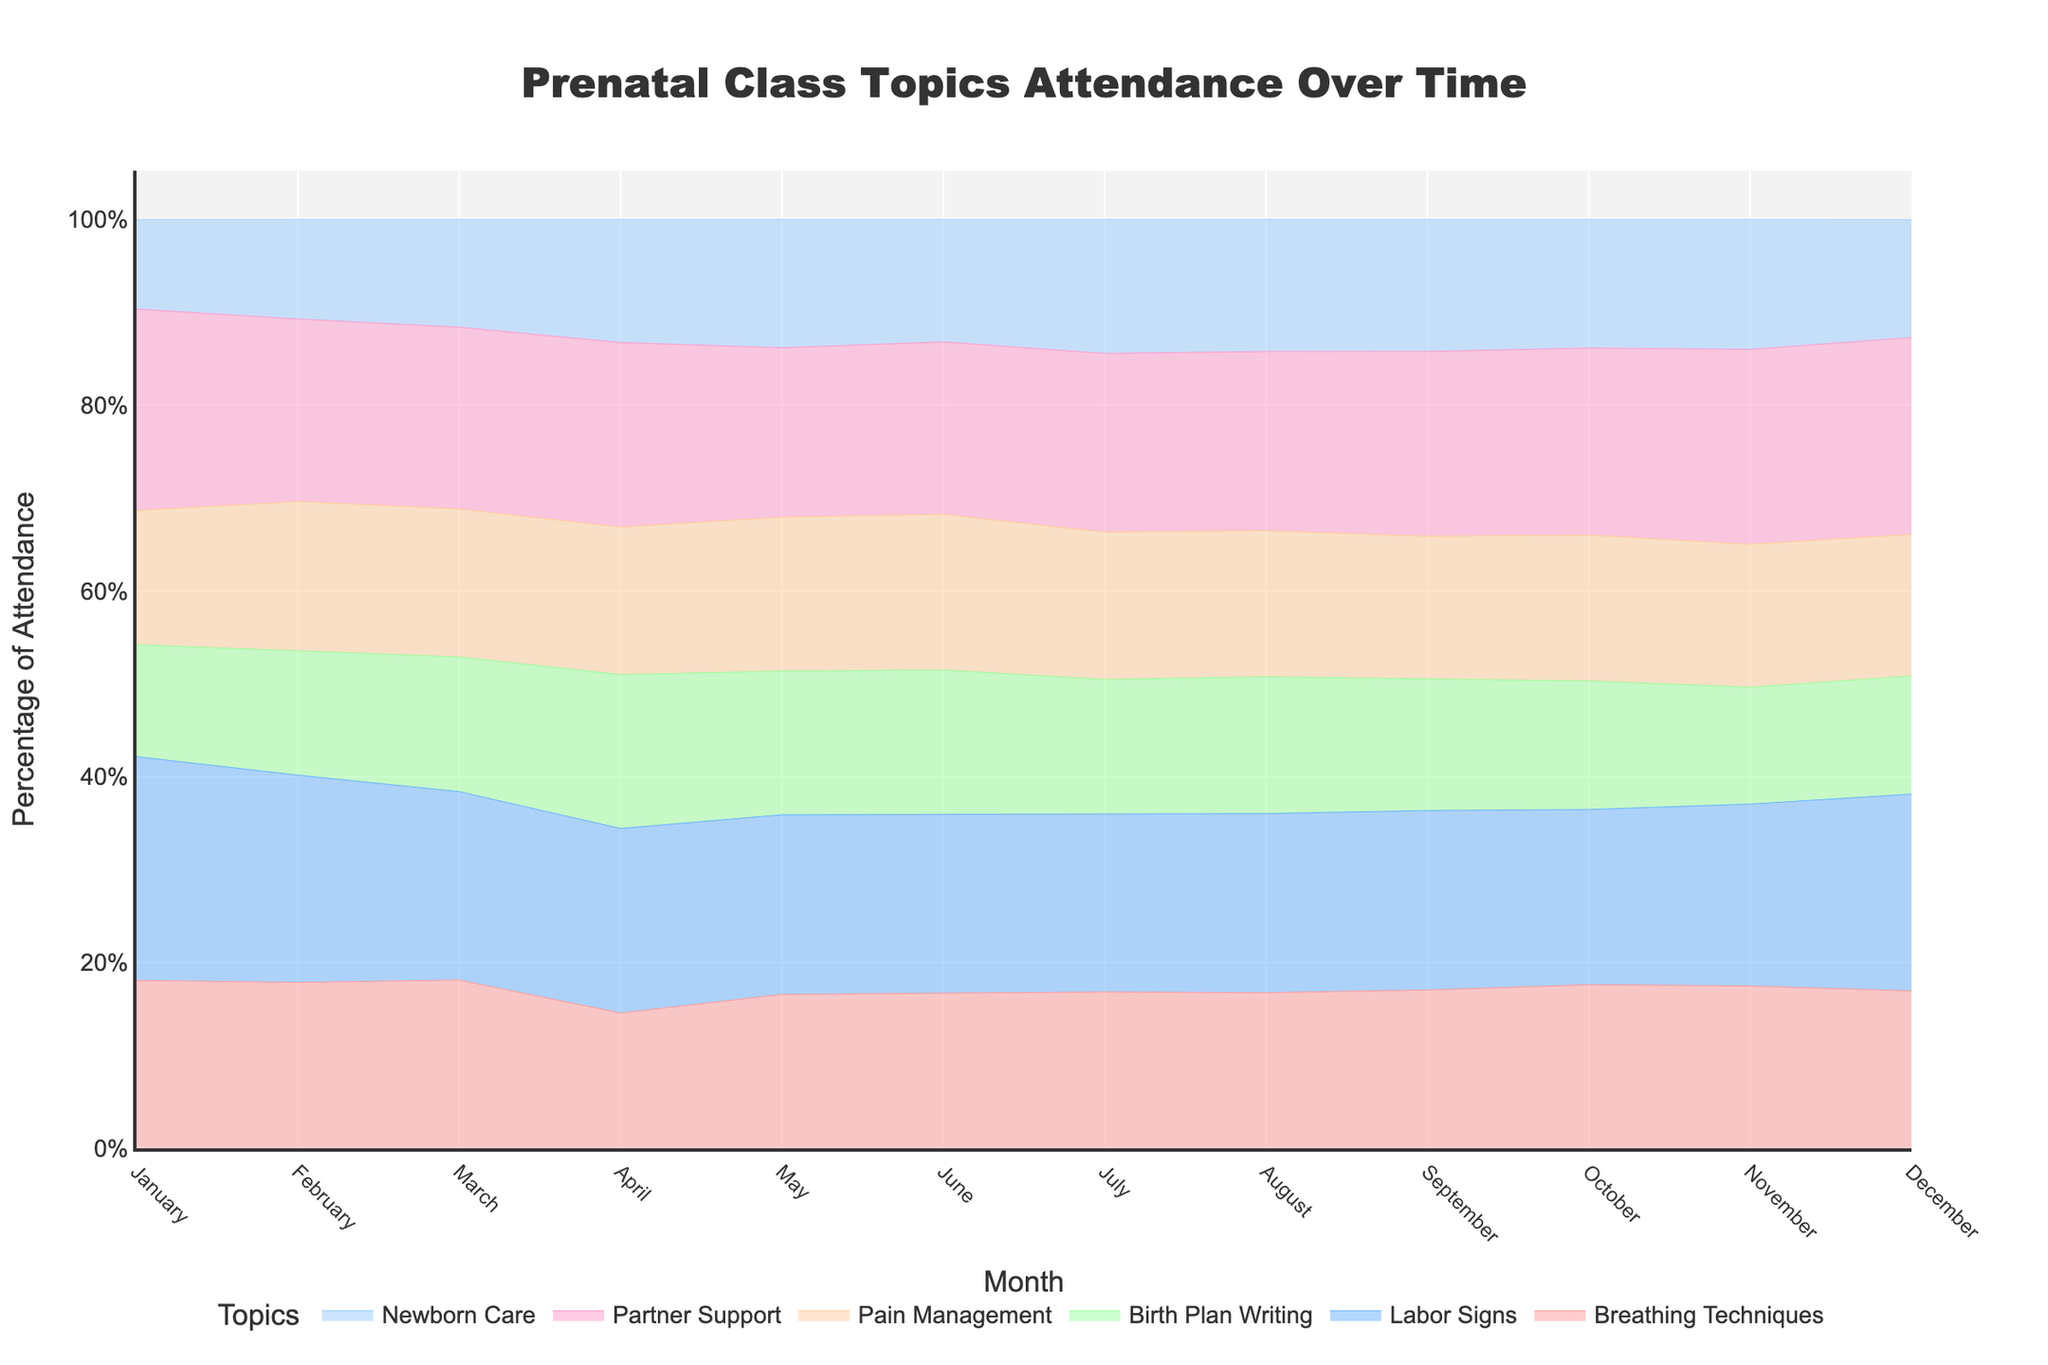How many different prenatal topics are shown in the chart? The chart represents the number of specific prenatal class topics. Count the different colors (or layers) in the chart to determine the number of topics.
Answer: Six What is the title of the chart? The title is located at the top of the chart and summarizes the content of the visual representation.
Answer: Prenatal Class Topics Attendance Over Time Which month had the highest percentage of attendance for "Newborn Care" classes? Observe the height of the area representing "Newborn Care" for each month. Determine the month with the highest value.
Answer: July During which months did the attendance for "Birth Plan Writing" exceed 20 participants? Look at the curve corresponding to "Birth Plan Writing" and identify the months when its value is above 20.
Answer: March, April, May, June, July, August, September In which month did participant attendance for "Pain Management" reach its peak? Examine the trend line for "Pain Management" and find the month where this line is at its highest point.
Answer: July What was the average number of participants for "Breathing Techniques" from January to June? Add the number of participants for "Breathing Techniques" from January to June and divide by the number of months (6). (15 + 20 + 25 + 22 + 30 + 28) / 6 = 140 / 6
Answer: 23.33 Compare the percentage change in attendance for "Partner Support" from January to July. Determine the difference in attendance from January to July for "Partner Support," then divide by the initial month's (January's) attendance and multiply by 100 for the percentage change. ((40 - 18) / 18) * 100
Answer: 122.22% During which months did the percentage attendance for "Labor Signs" remain above 30 participants? Review the data for "Labor Signs" and identify the months where the value is above 30.
Answer: April, May, July, August What was the trend of the "Breathing Techniques" class from March to November? Observe the line for "Breathing Techniques" from March to November and describe its pattern (upward, downward, or fluctuating).
Answer: Fluctuating Which prenatal topic had the least number of participants in December? Look for the lowest curve or smallest area in December’s column to identify the topic with the least participants.
Answer: Newborn Care 